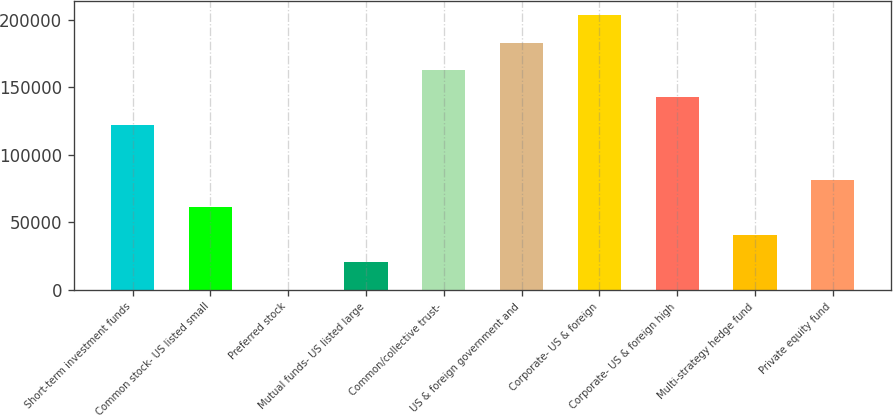Convert chart. <chart><loc_0><loc_0><loc_500><loc_500><bar_chart><fcel>Short-term investment funds<fcel>Common stock- US listed small<fcel>Preferred stock<fcel>Mutual funds- US listed large<fcel>Common/collective trust-<fcel>US & foreign government and<fcel>Corporate- US & foreign<fcel>Corporate- US & foreign high<fcel>Multi-strategy hedge fund<fcel>Private equity fund<nl><fcel>122126<fcel>61063.3<fcel>1<fcel>20355.1<fcel>162834<fcel>183188<fcel>203542<fcel>142480<fcel>40709.2<fcel>81417.4<nl></chart> 